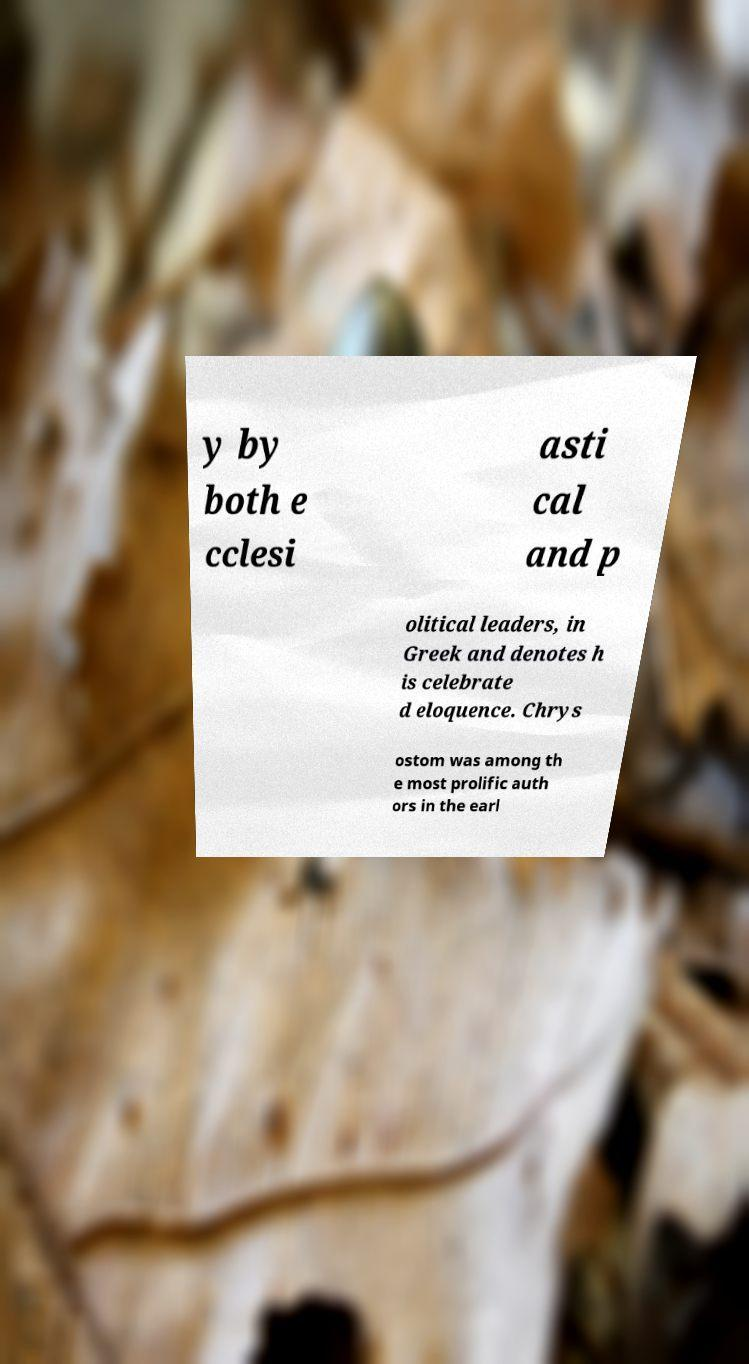Can you accurately transcribe the text from the provided image for me? y by both e cclesi asti cal and p olitical leaders, in Greek and denotes h is celebrate d eloquence. Chrys ostom was among th e most prolific auth ors in the earl 